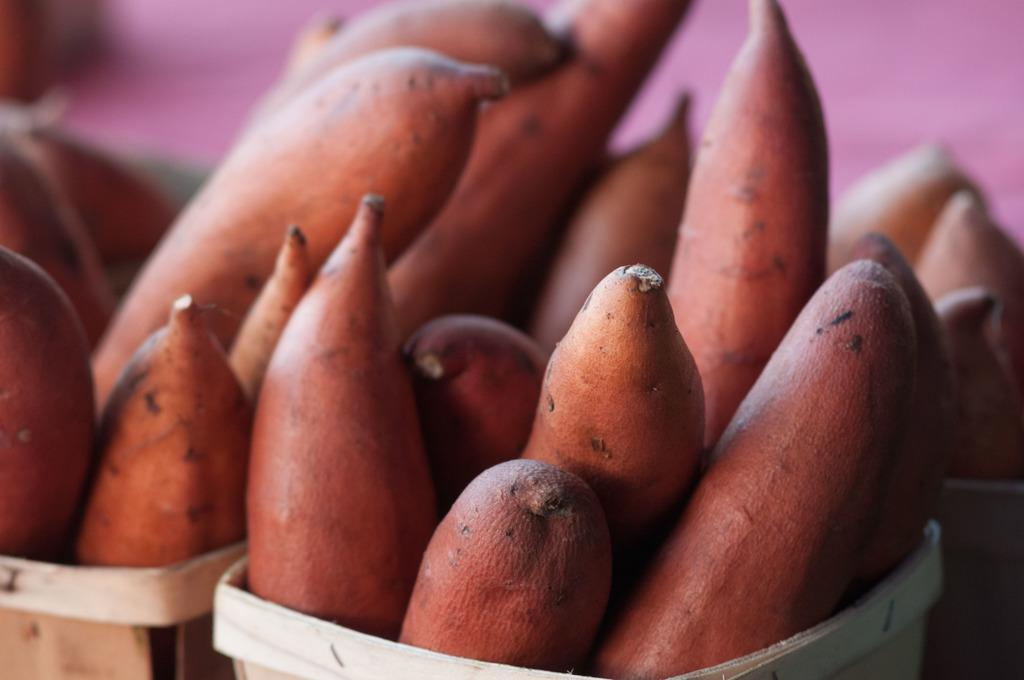What type of food is visible in the image? There are sweet potatoes in the image. How are the sweet potatoes stored or displayed? The sweet potatoes are stored in baskets. What is the aftermath of the rainstorm in the image? There is no mention of a rainstorm in the image, so it is not possible to describe its aftermath. 